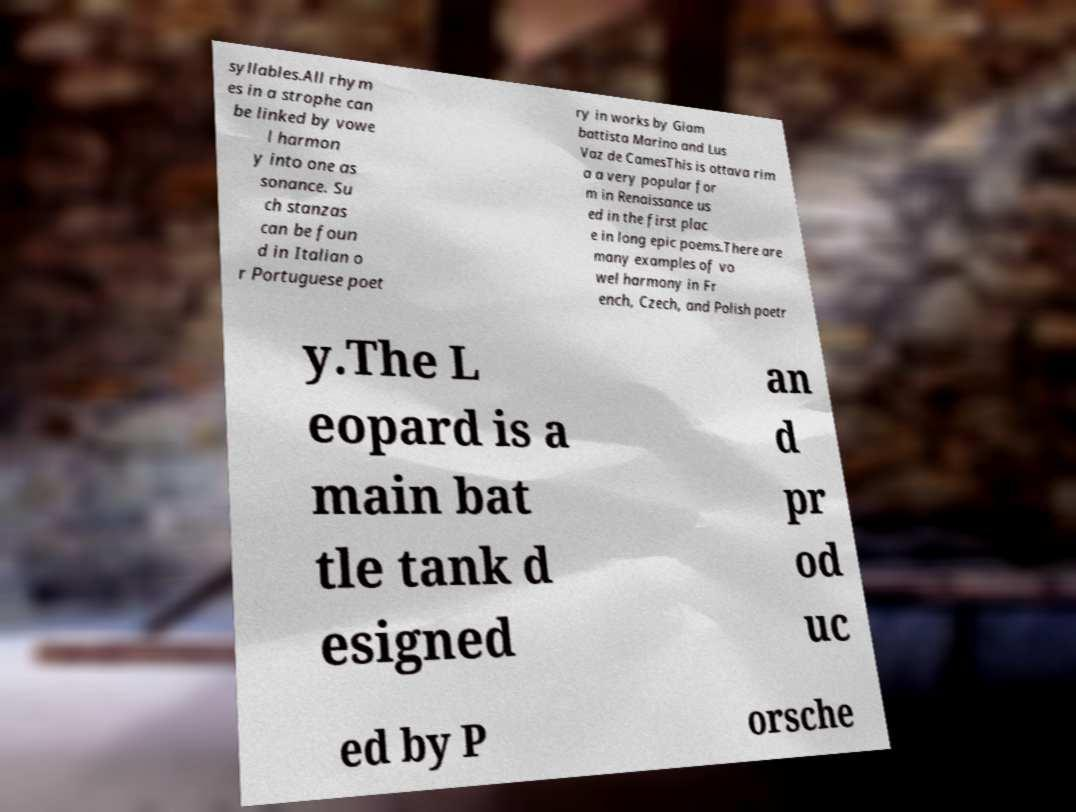For documentation purposes, I need the text within this image transcribed. Could you provide that? syllables.All rhym es in a strophe can be linked by vowe l harmon y into one as sonance. Su ch stanzas can be foun d in Italian o r Portuguese poet ry in works by Giam battista Marino and Lus Vaz de CamesThis is ottava rim a a very popular for m in Renaissance us ed in the first plac e in long epic poems.There are many examples of vo wel harmony in Fr ench, Czech, and Polish poetr y.The L eopard is a main bat tle tank d esigned an d pr od uc ed by P orsche 